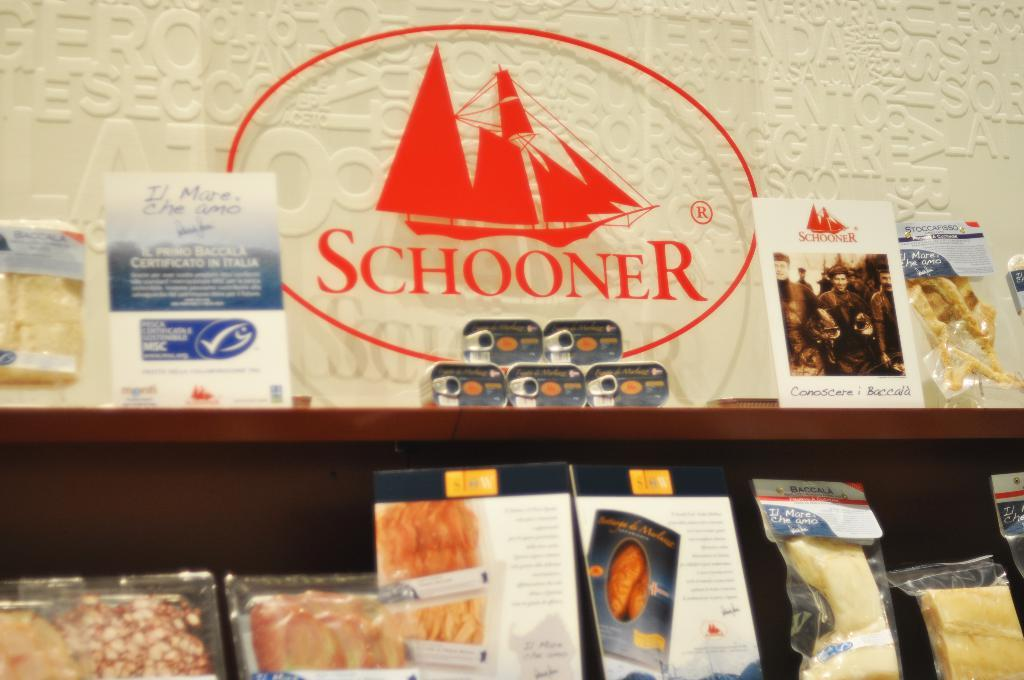What can be seen on the shelves in the image? There are objects on the shelves in the image. What is the color of the wall behind the shelves? There is a white wall in the background. What type of underwear is hanging on the wall in the image? There is no underwear present in the image. 